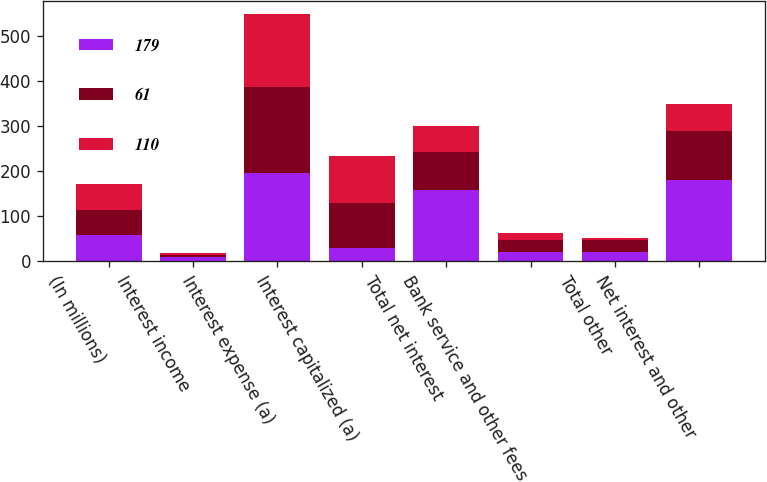<chart> <loc_0><loc_0><loc_500><loc_500><stacked_bar_chart><ecel><fcel>(In millions)<fcel>Interest income<fcel>Interest expense (a)<fcel>Interest capitalized (a)<fcel>Total net interest<fcel>Bank service and other fees<fcel>Total other<fcel>Net interest and other<nl><fcel>179<fcel>57<fcel>9<fcel>195<fcel>28<fcel>158<fcel>21<fcel>21<fcel>179<nl><fcel>61<fcel>57<fcel>5<fcel>191<fcel>101<fcel>85<fcel>25<fcel>25<fcel>110<nl><fcel>110<fcel>57<fcel>3<fcel>164<fcel>104<fcel>57<fcel>16<fcel>4<fcel>61<nl></chart> 